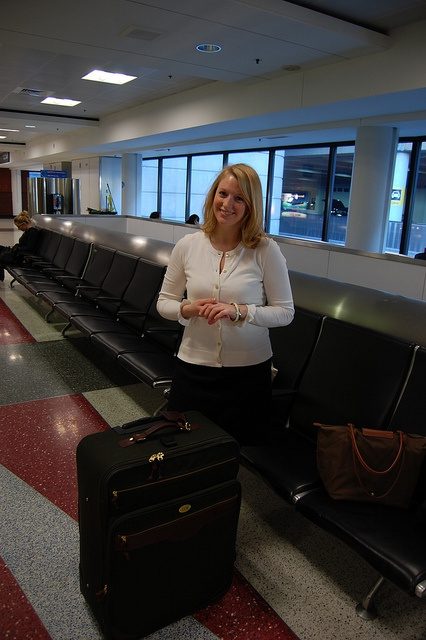Describe the objects in this image and their specific colors. I can see suitcase in black, maroon, olive, and gray tones, people in black, gray, and darkgray tones, chair in black, gray, maroon, and darkgreen tones, chair in black and gray tones, and handbag in black and maroon tones in this image. 